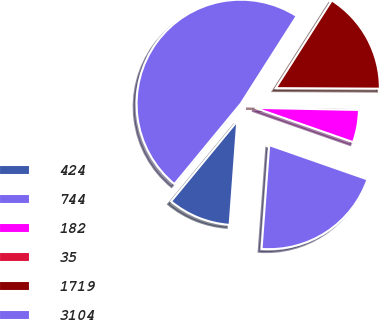Convert chart to OTSL. <chart><loc_0><loc_0><loc_500><loc_500><pie_chart><fcel>424<fcel>744<fcel>182<fcel>35<fcel>1719<fcel>3104<nl><fcel>9.81%<fcel>20.82%<fcel>5.03%<fcel>0.24%<fcel>16.04%<fcel>48.06%<nl></chart> 